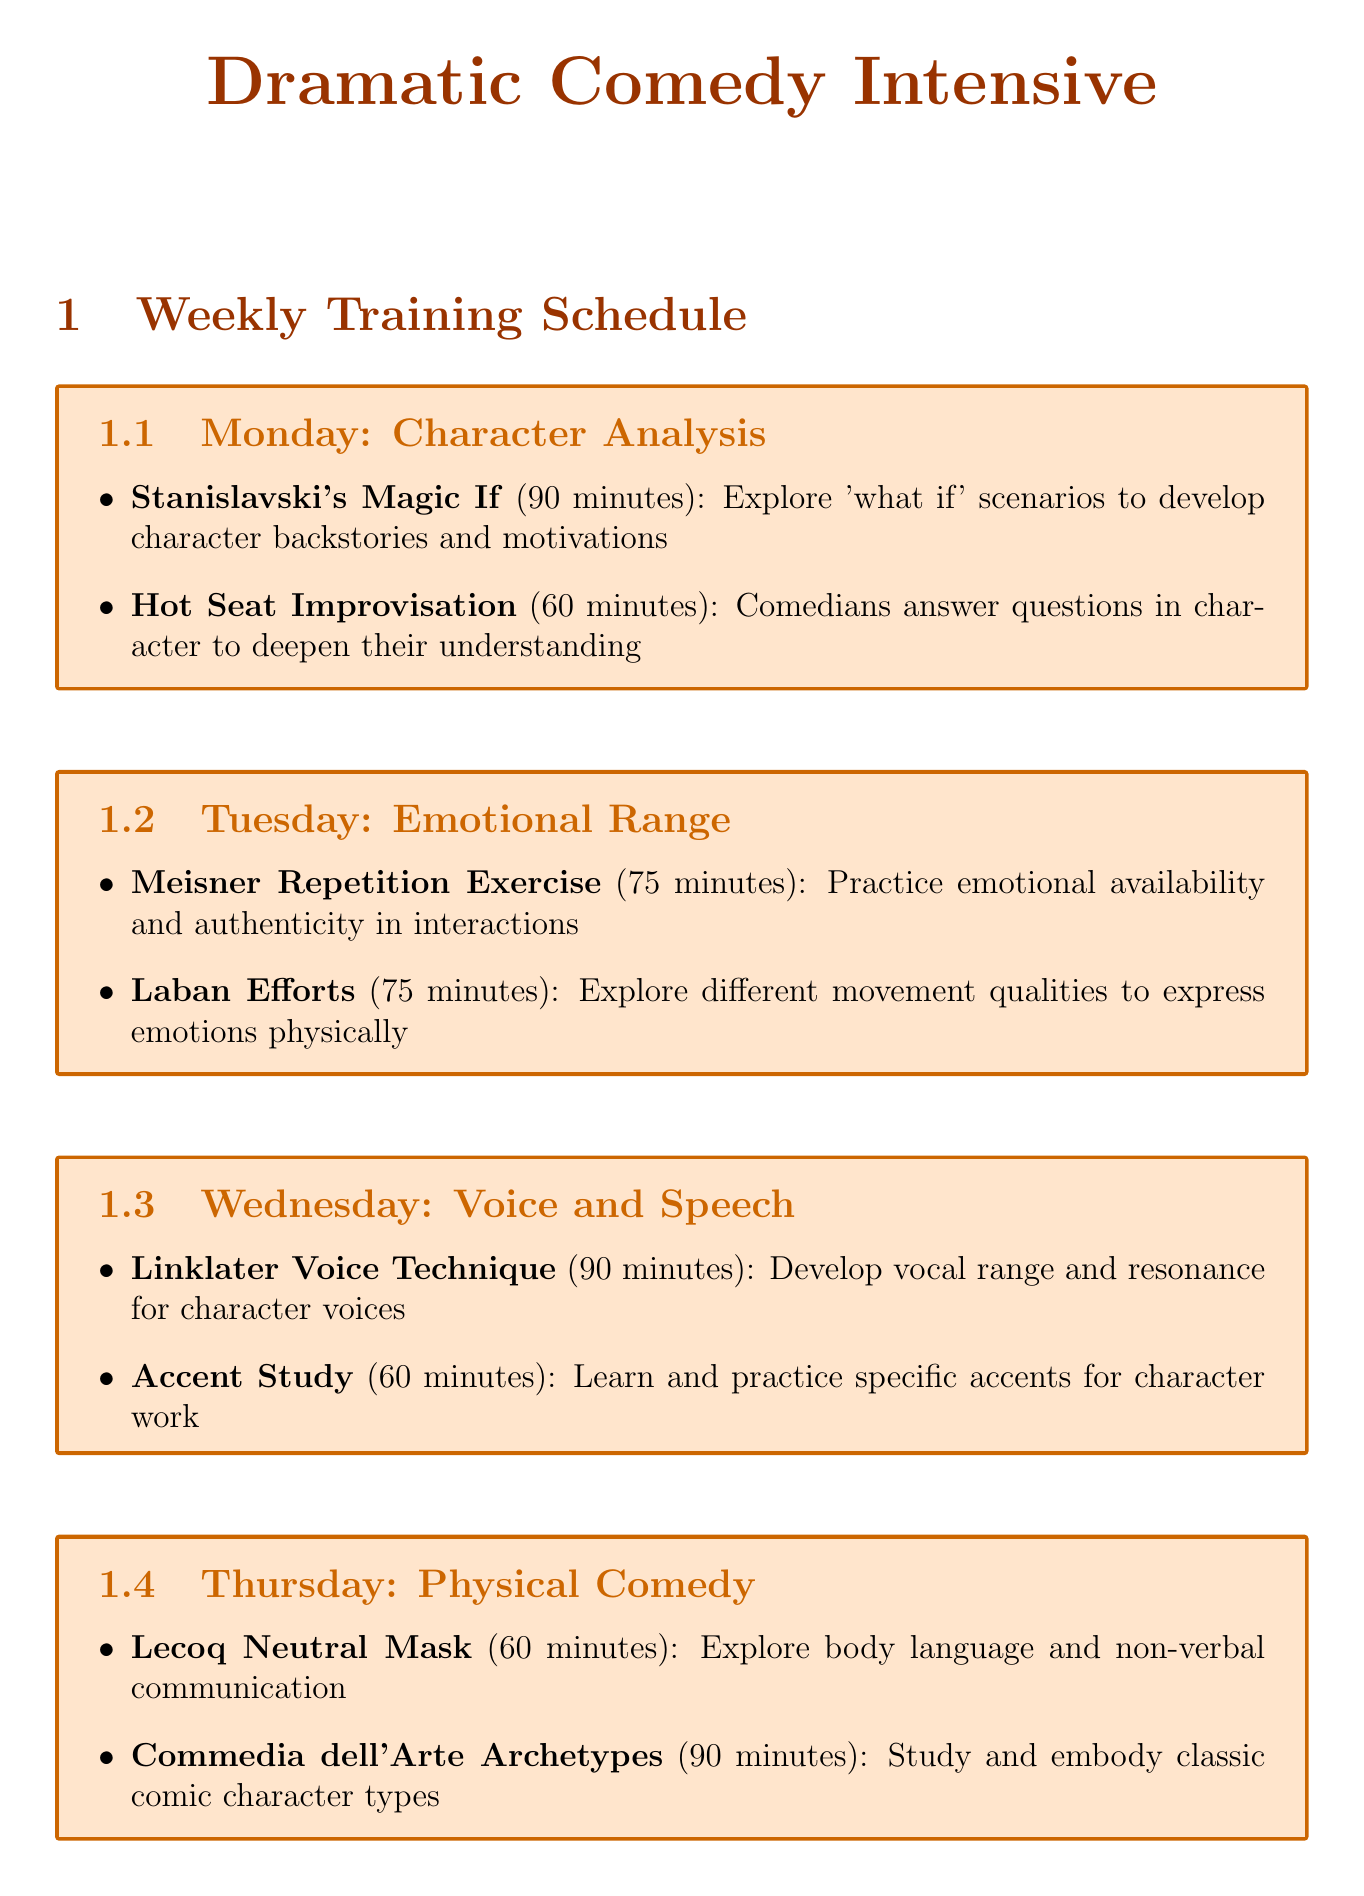What is the focus of Monday's session? The focus of Monday's session, as outlined in the document, is the specific theme or activity for that day.
Answer: Character Analysis How long is the Linklater Voice Technique activity? The duration of each activity is specified in the document, which is relevant to the timing.
Answer: 90 minutes What type of exercise is performed on Tuesday? The activities for each day include specific exercises that help develop skills, and Tuesday features a recognizable method of practice.
Answer: Meisner Repetition Exercise How many activities are scheduled for Thursday? The document lists the number of activities per day, which is important for understanding the structure of the training.
Answer: 2 What is the last activity on Sunday? Each day ends with a specific activity, and identifying the last activity gives insight into the weekly structure.
Answer: Feedback and Reflection Session What type of resources are listed? The additional resources provide tools for further learning, categorized in a specific way.
Answer: Book, TV Series, Online Courses, Streaming Service Which day focuses on Improvisation? Identifying the days dedicated to particular themes helps understand the training's organization.
Answer: Saturday What is the main goal of the Stand-up Character Showcase? The purpose of this activity is provided in the document, and understanding it clarifies the intention behind the exercise.
Answer: Perform developed characters in a stand-up format How long is the Hot Seat Improvisation activity? Each activity's duration is specifically mentioned, which helps with timing considerations for sessions.
Answer: 60 minutes 